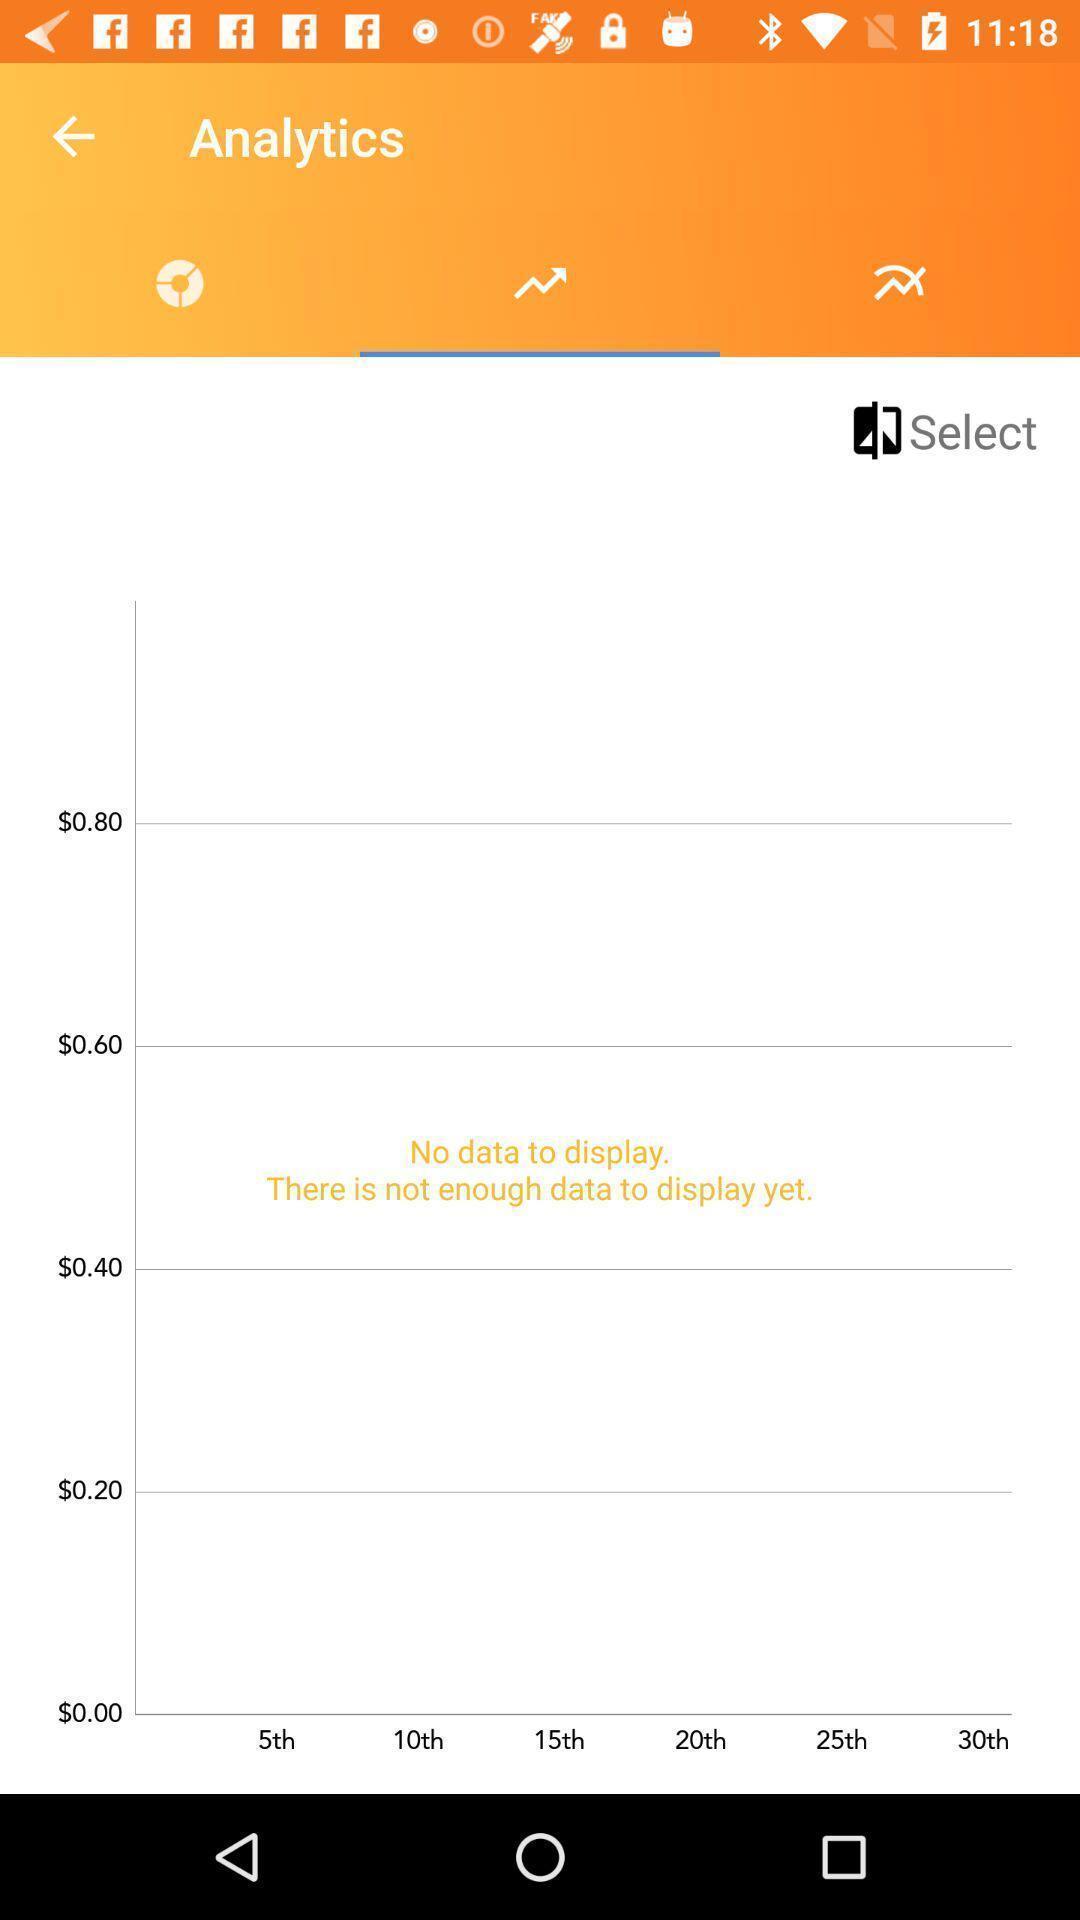What details can you identify in this image? Page showing the analytics using graph. 